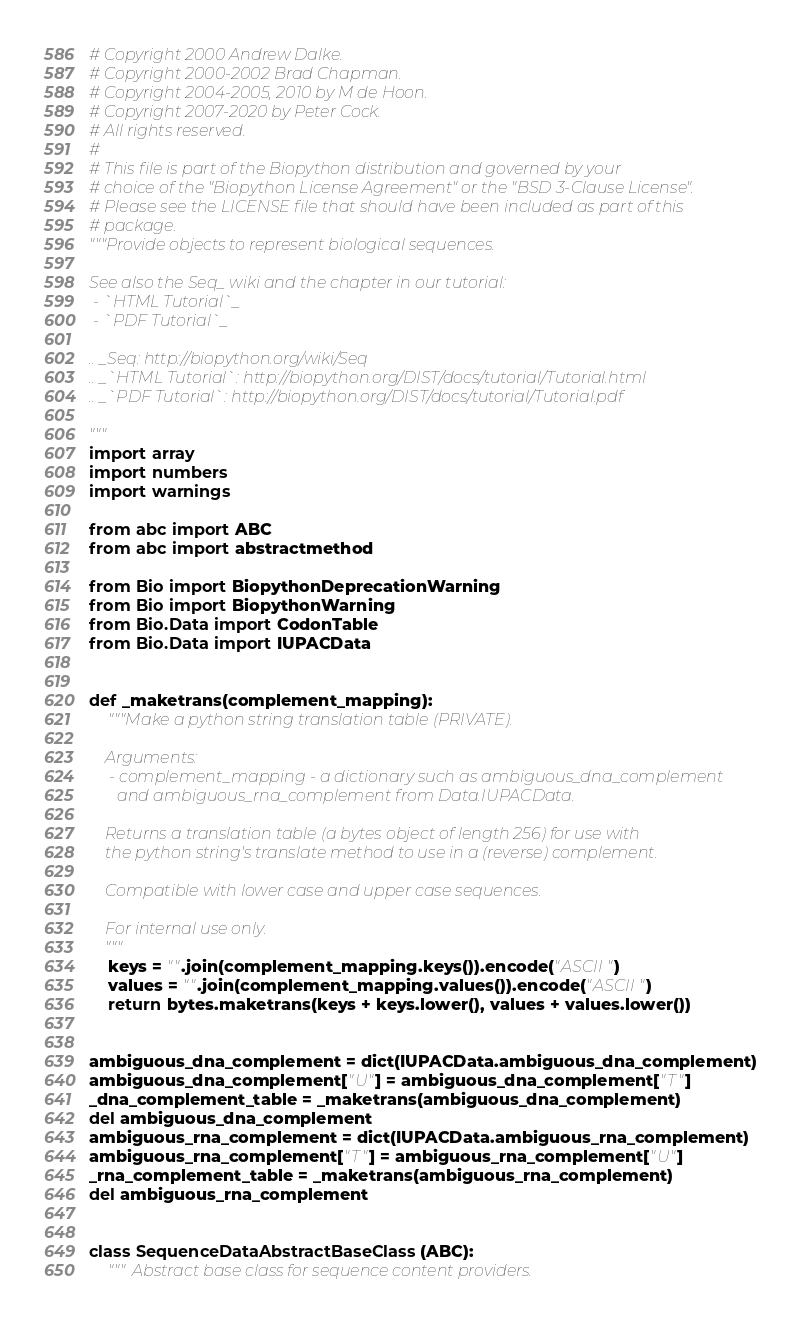Convert code to text. <code><loc_0><loc_0><loc_500><loc_500><_Python_># Copyright 2000 Andrew Dalke.
# Copyright 2000-2002 Brad Chapman.
# Copyright 2004-2005, 2010 by M de Hoon.
# Copyright 2007-2020 by Peter Cock.
# All rights reserved.
#
# This file is part of the Biopython distribution and governed by your
# choice of the "Biopython License Agreement" or the "BSD 3-Clause License".
# Please see the LICENSE file that should have been included as part of this
# package.
"""Provide objects to represent biological sequences.

See also the Seq_ wiki and the chapter in our tutorial:
 - `HTML Tutorial`_
 - `PDF Tutorial`_

.. _Seq: http://biopython.org/wiki/Seq
.. _`HTML Tutorial`: http://biopython.org/DIST/docs/tutorial/Tutorial.html
.. _`PDF Tutorial`: http://biopython.org/DIST/docs/tutorial/Tutorial.pdf

"""
import array
import numbers
import warnings

from abc import ABC
from abc import abstractmethod

from Bio import BiopythonDeprecationWarning
from Bio import BiopythonWarning
from Bio.Data import CodonTable
from Bio.Data import IUPACData


def _maketrans(complement_mapping):
    """Make a python string translation table (PRIVATE).

    Arguments:
     - complement_mapping - a dictionary such as ambiguous_dna_complement
       and ambiguous_rna_complement from Data.IUPACData.

    Returns a translation table (a bytes object of length 256) for use with
    the python string's translate method to use in a (reverse) complement.

    Compatible with lower case and upper case sequences.

    For internal use only.
    """
    keys = "".join(complement_mapping.keys()).encode("ASCII")
    values = "".join(complement_mapping.values()).encode("ASCII")
    return bytes.maketrans(keys + keys.lower(), values + values.lower())


ambiguous_dna_complement = dict(IUPACData.ambiguous_dna_complement)
ambiguous_dna_complement["U"] = ambiguous_dna_complement["T"]
_dna_complement_table = _maketrans(ambiguous_dna_complement)
del ambiguous_dna_complement
ambiguous_rna_complement = dict(IUPACData.ambiguous_rna_complement)
ambiguous_rna_complement["T"] = ambiguous_rna_complement["U"]
_rna_complement_table = _maketrans(ambiguous_rna_complement)
del ambiguous_rna_complement


class SequenceDataAbstractBaseClass(ABC):
    """Abstract base class for sequence content providers.
</code> 